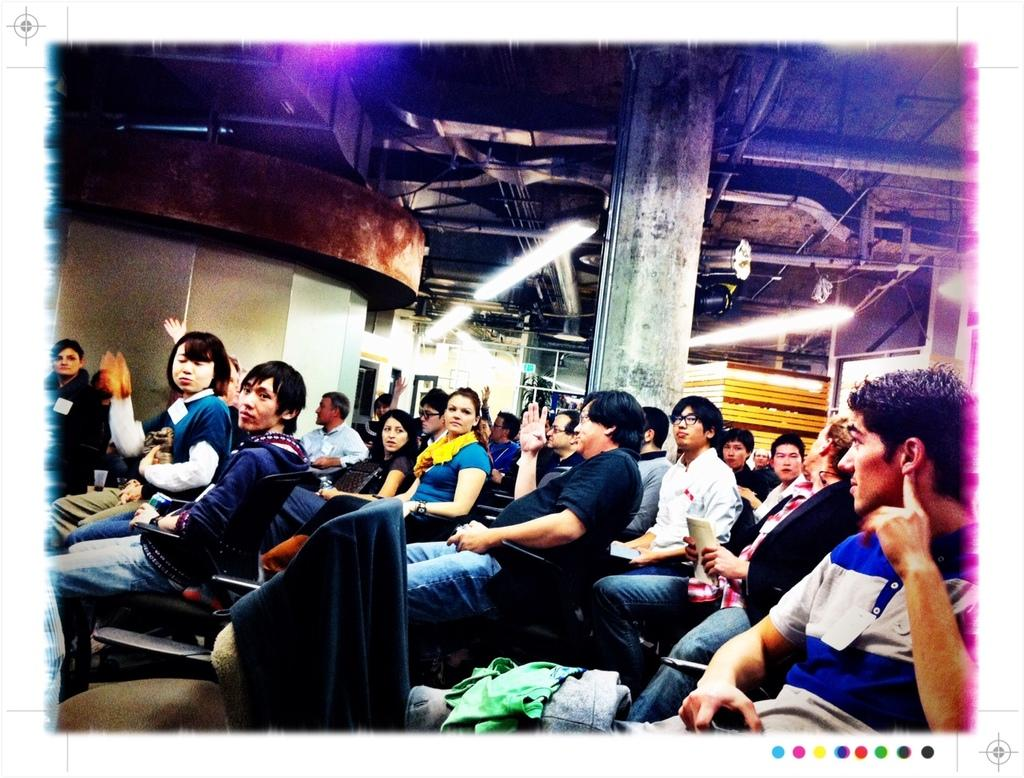What is the main activity of the people in the image? The people in the image are sitting in chairs. What structure can be seen in the middle of the image? There is a pillar in the middle of the image. What is above the people in the image? There is a roof at the top of the image. What is on the left side of the image? There is a wall on the left side of the image. How many pies are being served on the wall in the image? There are no pies visible in the image, and the wall does not appear to be serving any food items. 